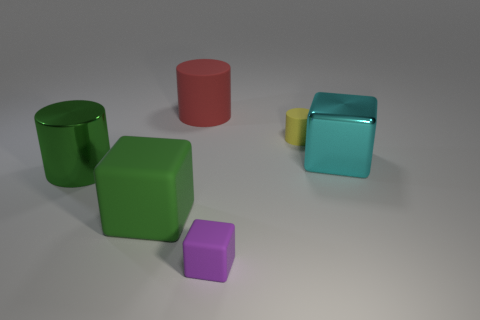Subtract all big cyan shiny blocks. How many blocks are left? 2 Subtract 1 cylinders. How many cylinders are left? 2 Add 4 small cylinders. How many objects exist? 10 Subtract all purple cylinders. Subtract all green cubes. How many cylinders are left? 3 Add 1 tiny gray metallic cylinders. How many tiny gray metallic cylinders exist? 1 Subtract 1 cyan blocks. How many objects are left? 5 Subtract all red cylinders. Subtract all big matte cylinders. How many objects are left? 4 Add 1 large metal cylinders. How many large metal cylinders are left? 2 